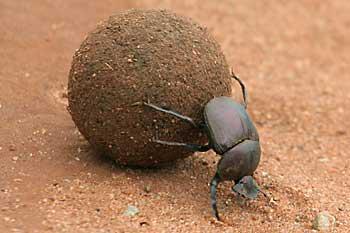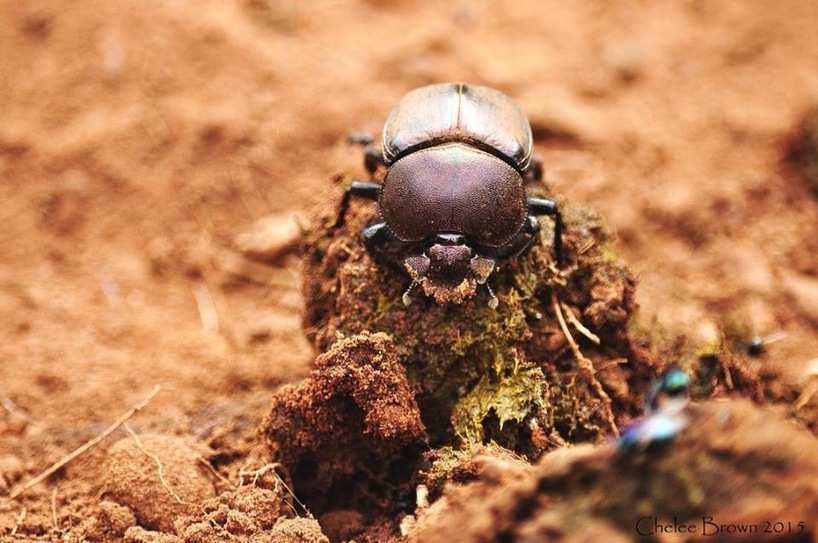The first image is the image on the left, the second image is the image on the right. Given the left and right images, does the statement "No rounded, dimensional shape is visible beneath the beetle in the right image." hold true? Answer yes or no. No. The first image is the image on the left, the second image is the image on the right. Given the left and right images, does the statement "There are two beetles on a clod of dirt in one of the images." hold true? Answer yes or no. No. 